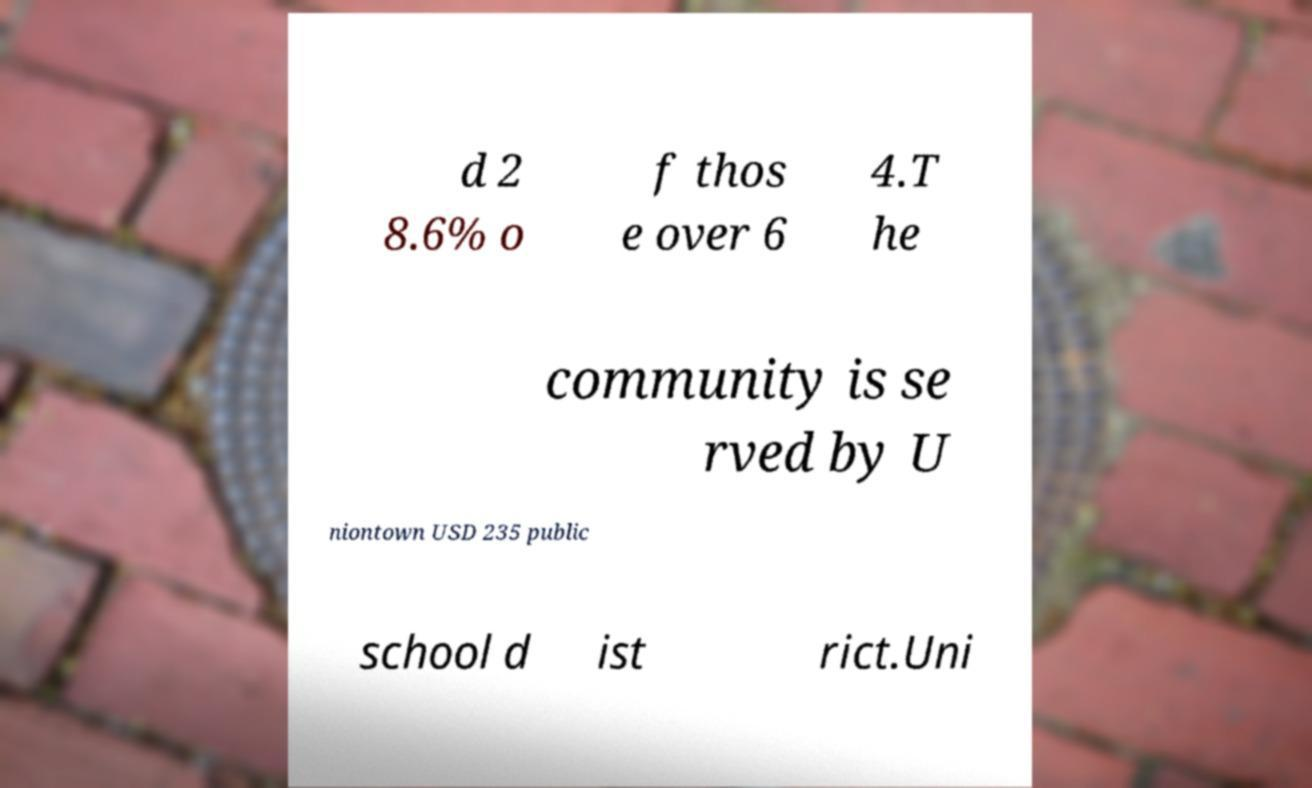Please read and relay the text visible in this image. What does it say? d 2 8.6% o f thos e over 6 4.T he community is se rved by U niontown USD 235 public school d ist rict.Uni 